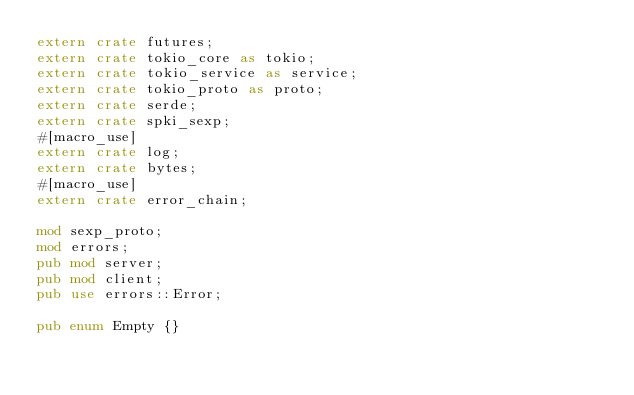Convert code to text. <code><loc_0><loc_0><loc_500><loc_500><_Rust_>extern crate futures;
extern crate tokio_core as tokio;
extern crate tokio_service as service;
extern crate tokio_proto as proto;
extern crate serde;
extern crate spki_sexp;
#[macro_use]
extern crate log;
extern crate bytes;
#[macro_use]
extern crate error_chain;

mod sexp_proto;
mod errors;
pub mod server;
pub mod client;
pub use errors::Error;

pub enum Empty {}
</code> 